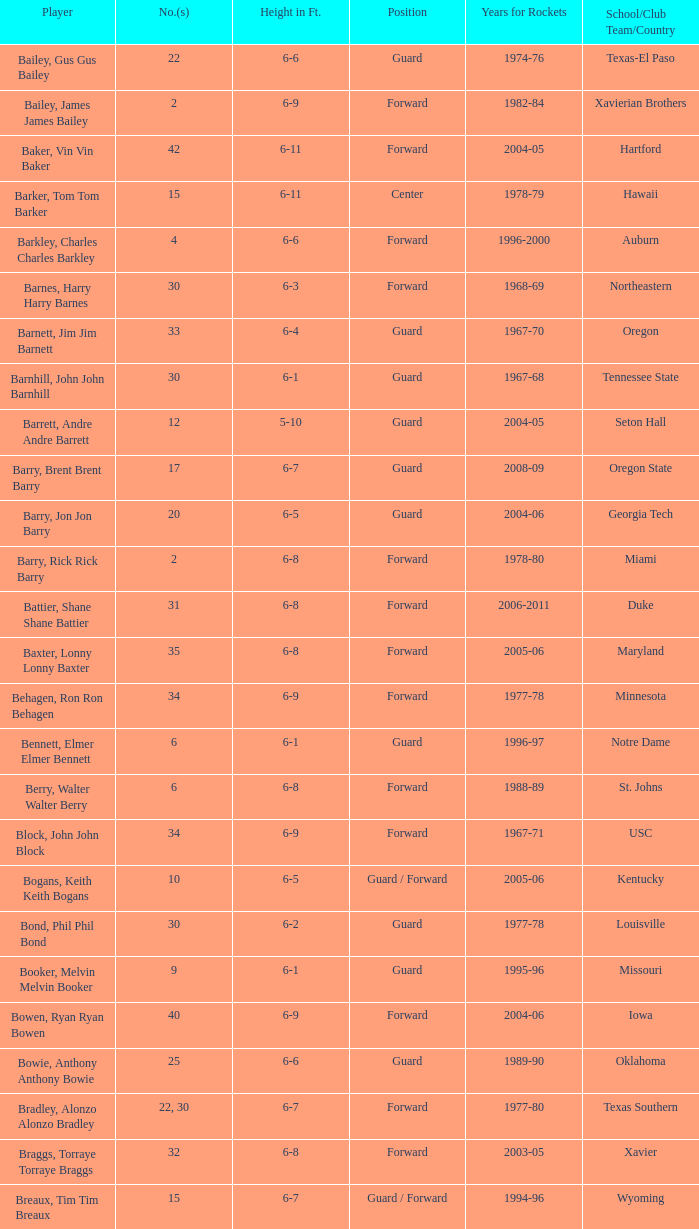What years did the player from LaSalle play for the Rockets? 1982-83. Can you parse all the data within this table? {'header': ['Player', 'No.(s)', 'Height in Ft.', 'Position', 'Years for Rockets', 'School/Club Team/Country'], 'rows': [['Bailey, Gus Gus Bailey', '22', '6-6', 'Guard', '1974-76', 'Texas-El Paso'], ['Bailey, James James Bailey', '2', '6-9', 'Forward', '1982-84', 'Xavierian Brothers'], ['Baker, Vin Vin Baker', '42', '6-11', 'Forward', '2004-05', 'Hartford'], ['Barker, Tom Tom Barker', '15', '6-11', 'Center', '1978-79', 'Hawaii'], ['Barkley, Charles Charles Barkley', '4', '6-6', 'Forward', '1996-2000', 'Auburn'], ['Barnes, Harry Harry Barnes', '30', '6-3', 'Forward', '1968-69', 'Northeastern'], ['Barnett, Jim Jim Barnett', '33', '6-4', 'Guard', '1967-70', 'Oregon'], ['Barnhill, John John Barnhill', '30', '6-1', 'Guard', '1967-68', 'Tennessee State'], ['Barrett, Andre Andre Barrett', '12', '5-10', 'Guard', '2004-05', 'Seton Hall'], ['Barry, Brent Brent Barry', '17', '6-7', 'Guard', '2008-09', 'Oregon State'], ['Barry, Jon Jon Barry', '20', '6-5', 'Guard', '2004-06', 'Georgia Tech'], ['Barry, Rick Rick Barry', '2', '6-8', 'Forward', '1978-80', 'Miami'], ['Battier, Shane Shane Battier', '31', '6-8', 'Forward', '2006-2011', 'Duke'], ['Baxter, Lonny Lonny Baxter', '35', '6-8', 'Forward', '2005-06', 'Maryland'], ['Behagen, Ron Ron Behagen', '34', '6-9', 'Forward', '1977-78', 'Minnesota'], ['Bennett, Elmer Elmer Bennett', '6', '6-1', 'Guard', '1996-97', 'Notre Dame'], ['Berry, Walter Walter Berry', '6', '6-8', 'Forward', '1988-89', 'St. Johns'], ['Block, John John Block', '34', '6-9', 'Forward', '1967-71', 'USC'], ['Bogans, Keith Keith Bogans', '10', '6-5', 'Guard / Forward', '2005-06', 'Kentucky'], ['Bond, Phil Phil Bond', '30', '6-2', 'Guard', '1977-78', 'Louisville'], ['Booker, Melvin Melvin Booker', '9', '6-1', 'Guard', '1995-96', 'Missouri'], ['Bowen, Ryan Ryan Bowen', '40', '6-9', 'Forward', '2004-06', 'Iowa'], ['Bowie, Anthony Anthony Bowie', '25', '6-6', 'Guard', '1989-90', 'Oklahoma'], ['Bradley, Alonzo Alonzo Bradley', '22, 30', '6-7', 'Forward', '1977-80', 'Texas Southern'], ['Braggs, Torraye Torraye Braggs', '32', '6-8', 'Forward', '2003-05', 'Xavier'], ['Breaux, Tim Tim Breaux', '15', '6-7', 'Guard / Forward', '1994-96', 'Wyoming'], ['Britt, Tyrone Tyrone Britt', '31', '6-4', 'Guard', '1967-68', 'Johnson C. Smith'], ['Brooks, Aaron Aaron Brooks', '0', '6-0', 'Guard', '2007-2011, 2013', 'Oregon'], ['Brooks, Scott Scott Brooks', '1', '5-11', 'Guard', '1992-95', 'UC-Irvine'], ['Brown, Chucky Chucky Brown', '52', '6-8', 'Forward', '1994-96', 'North Carolina'], ['Brown, Tony Tony Brown', '35', '6-6', 'Forward', '1988-89', 'Arkansas'], ['Brown, Tierre Tierre Brown', '10', '6-2', 'Guard', '2001-02', 'McNesse State'], ['Brunson, Rick Rick Brunson', '9', '6-4', 'Guard', '2005-06', 'Temple'], ['Bryant, Joe Joe Bryant', '22', '6-9', 'Forward / Guard', '1982-83', 'LaSalle'], ['Bryant, Mark Mark Bryant', '2', '6-9', 'Forward', '1995-96', 'Seton Hall'], ['Budinger, Chase Chase Budinger', '10', '6-7', 'Forward', '2009-2012', 'Arizona'], ['Bullard, Matt Matt Bullard', '50', '6-10', 'Forward', '1990-94, 1996-2001', 'Iowa']]} 